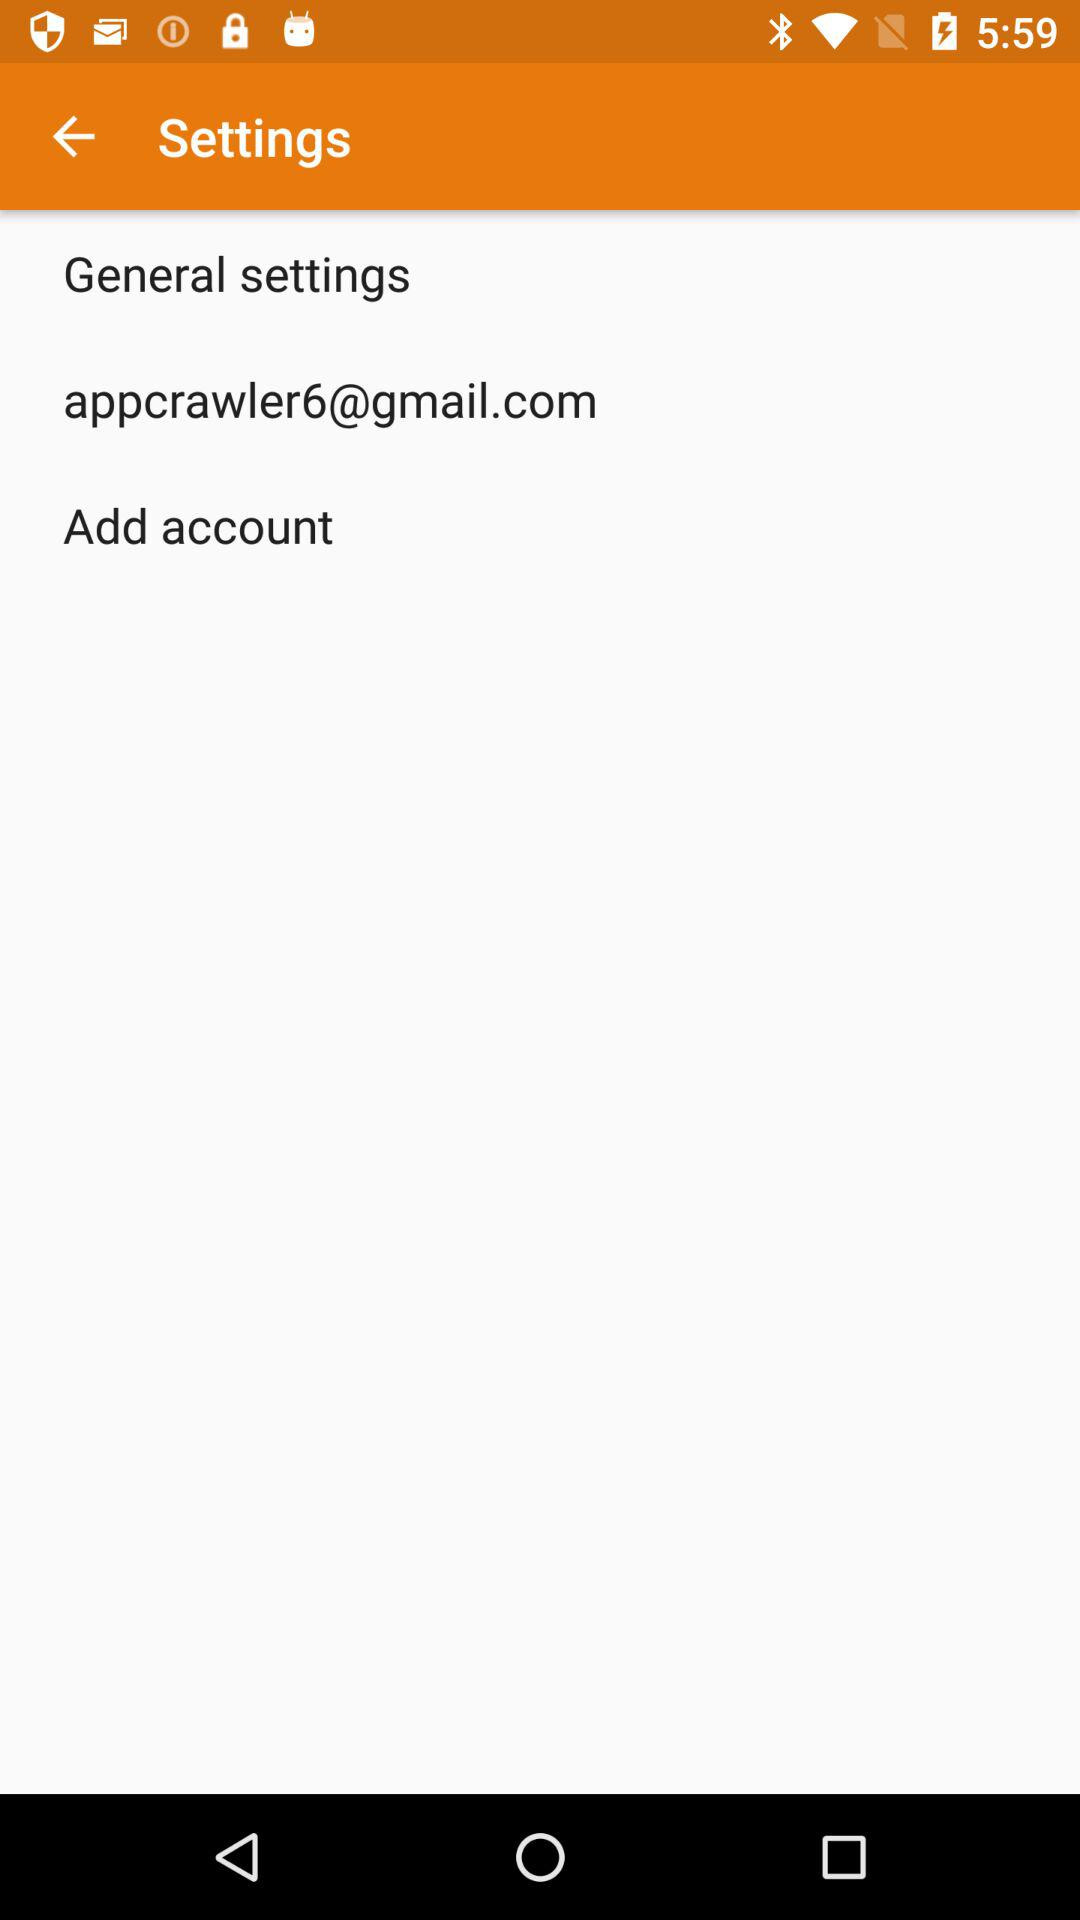What is the email address? The email address is appcrawler6@gmail.com. 